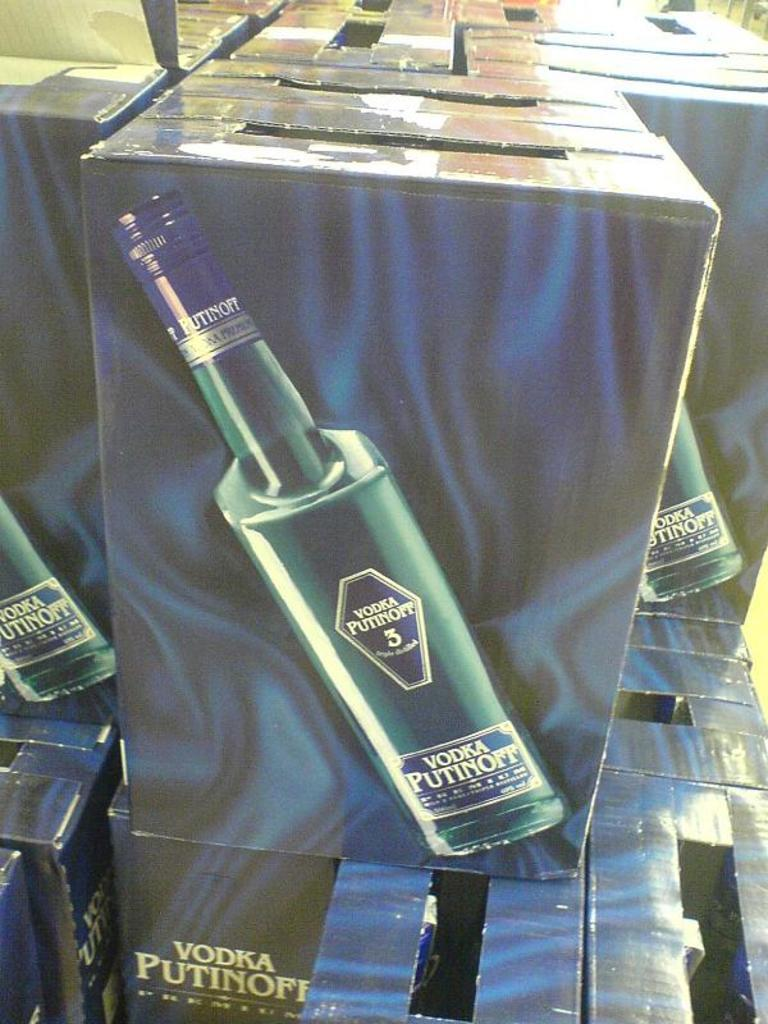<image>
Describe the image concisely. The boxes shown contain many bottles of vodka. 